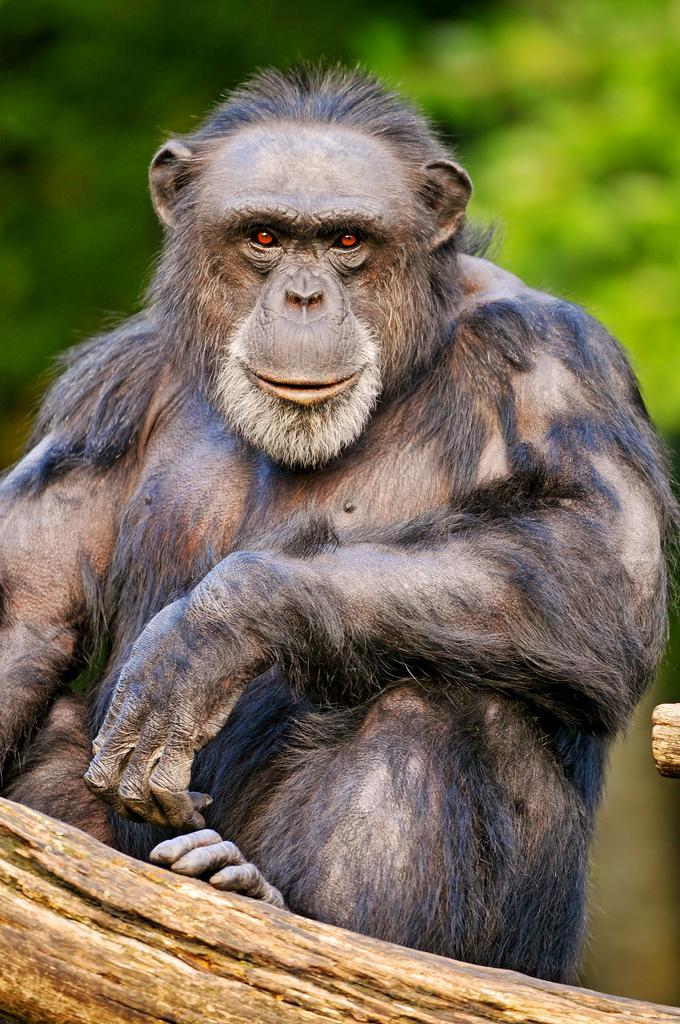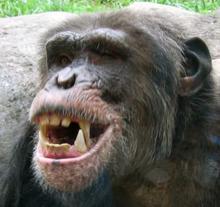The first image is the image on the left, the second image is the image on the right. For the images displayed, is the sentence "The primate in the image on the left has its mouth wide open." factually correct? Answer yes or no. No. The first image is the image on the left, the second image is the image on the right. Examine the images to the left and right. Is the description "Each image contains the face of an ape with teeth showing, and at least one image shows a wide-open mouth." accurate? Answer yes or no. No. 